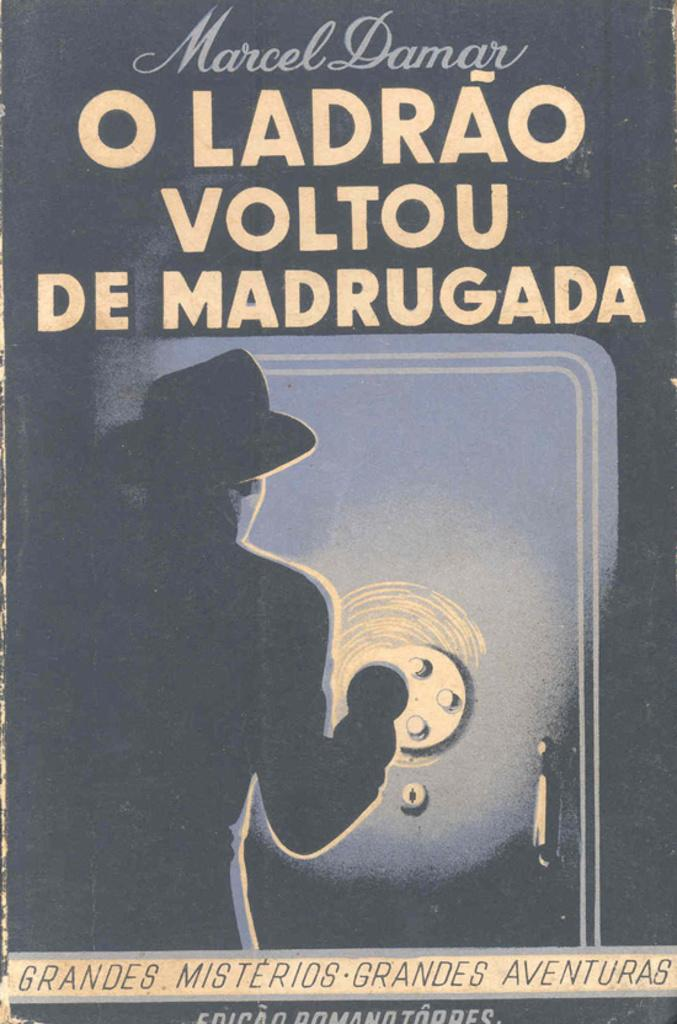<image>
Give a short and clear explanation of the subsequent image. An old poster of a guy shining a light on a large safe with the words O Ladrao Voltou De Madrugada on it. 